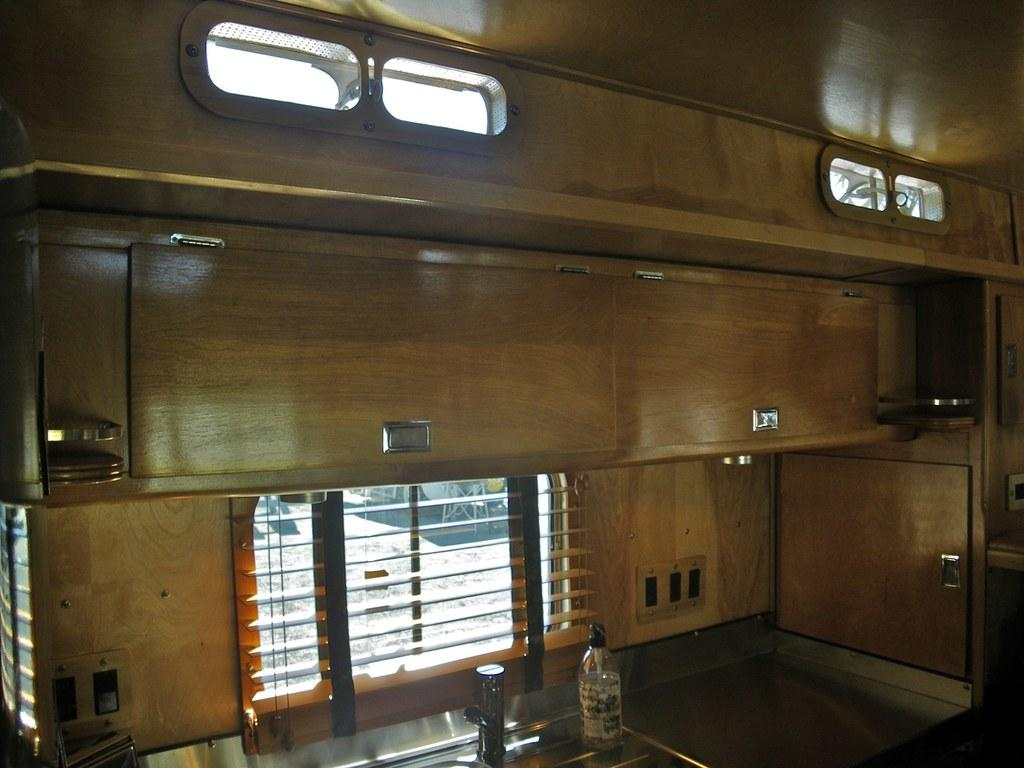What object in the image is used for dispensing water? There is a tap in the image that is used for dispensing water. What object in the image can be used for storing liquid? There is a bottle in the image that can be used for storing liquid. What feature in the image allows natural light to enter the space? There is a window in the image that allows natural light to enter the space. What device in the image helps circulate air? There is a ventilator in the image that helps circulate air. How many apples are on the table in the image? There are no apples present in the image. What type of trip is being taken by the sisters in the image? There are no sisters or trip depicted in the image. 